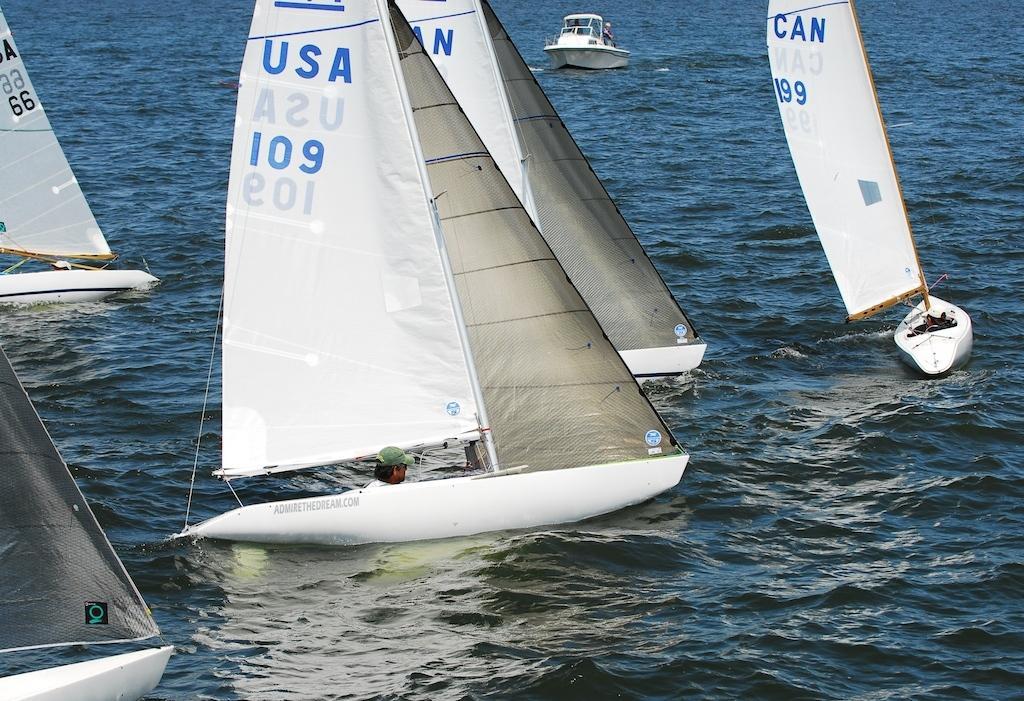Could you give a brief overview of what you see in this image? In this image I can see boats are floating on water. In these boats there are people. 